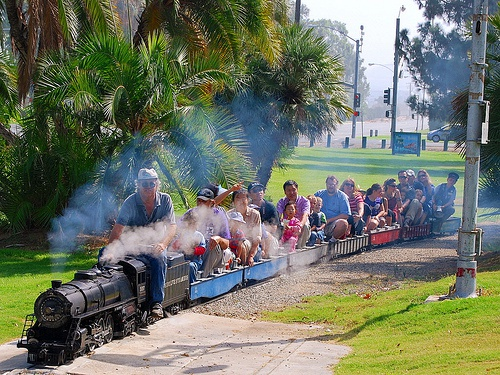Describe the objects in this image and their specific colors. I can see train in darkgreen, black, gray, and darkgray tones, people in darkgreen, darkgray, gray, navy, and black tones, people in darkgreen, darkgray, gray, maroon, and black tones, people in darkgreen, darkgray, gray, and navy tones, and people in darkgreen, gray, and blue tones in this image. 